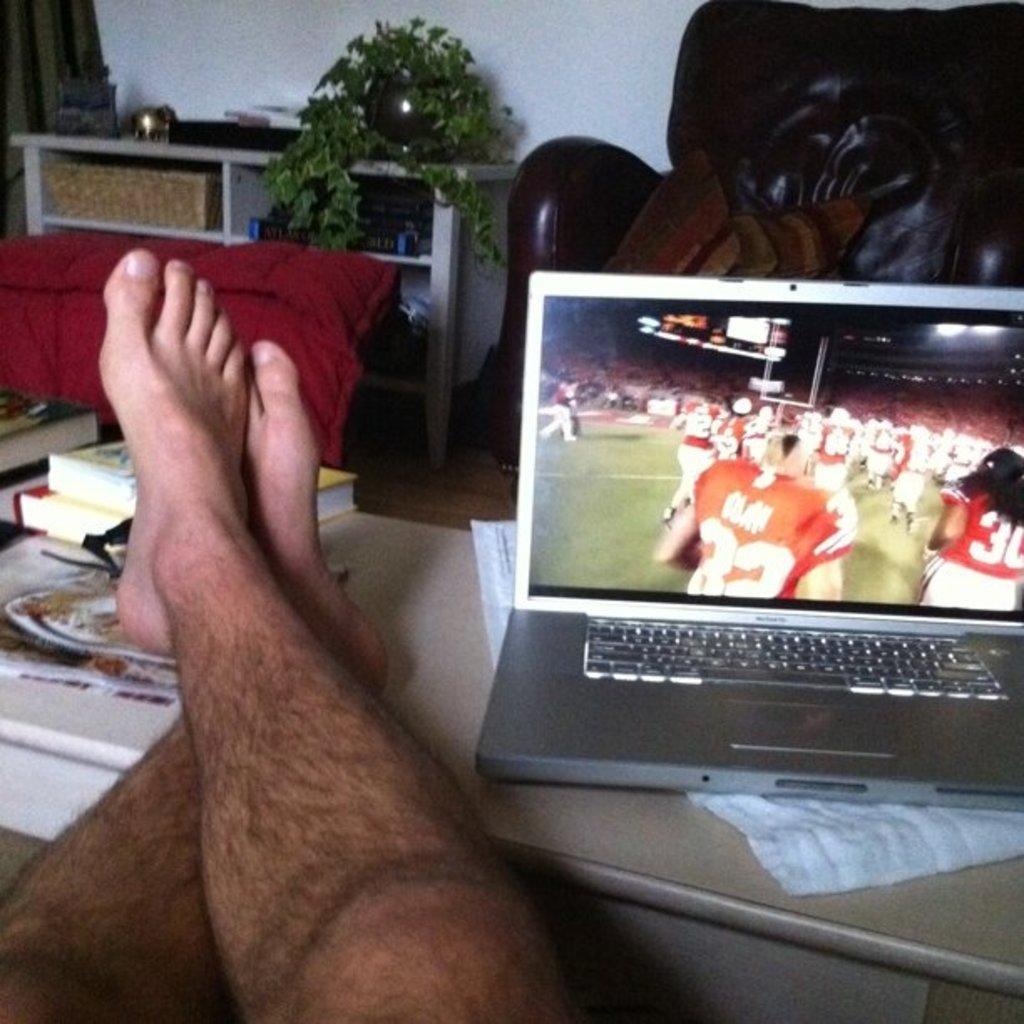Describe this image in one or two sentences. In the picture we can see a desk with a laptop on the white color cloth and besides, we can see some books and persons legs are kept and in the background, we can see some racks and on it we can see a house plant and besides, we can see some sofa with a pillow and to the floor we can see a red color sofa near the racks. 